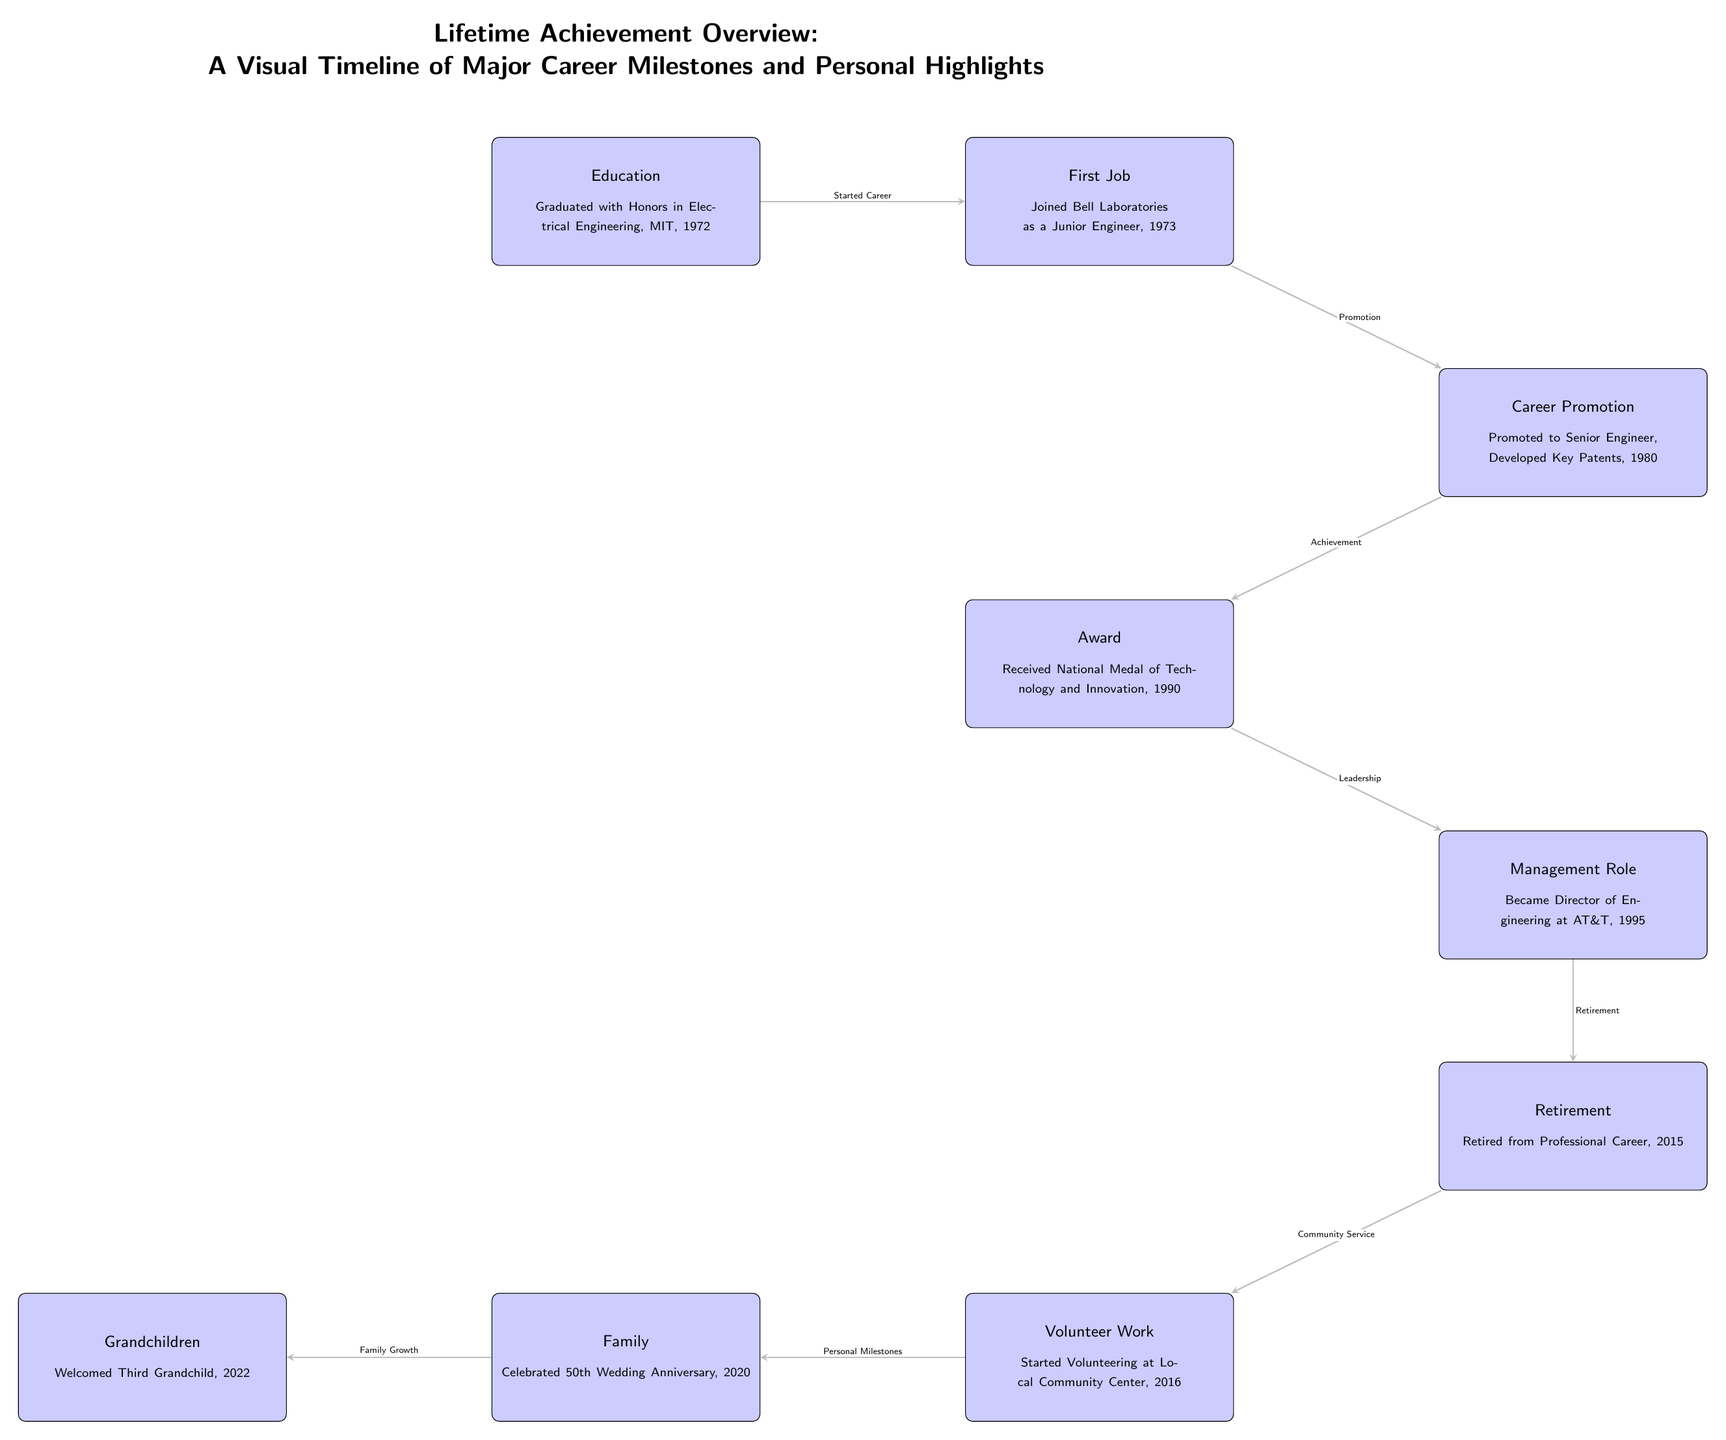What year did the retirement occur? The retirement event is represented in the diagram. By examining the node labeled 'Retirement,' it notes that the retirement occurred in 2015.
Answer: 2015 How many major career milestones are shown in the diagram? Counting the nodes that represent career milestones only (Education, First Job, Career Promotion, Award, Management Role, Retirement), we find a total of six nodes indicating major career milestones.
Answer: 6 What was the first job mentioned? Looking at the node labeled 'First Job,' it specifies that the first job was at Bell Laboratories as a Junior Engineer.
Answer: Joined Bell Laboratories as a Junior Engineer What event followed the career promotion? By analyzing the flow of the diagram, the event that follows 'Career Promotion' is 'Award,' as indicated by the connecting arrow between these two nodes.
Answer: Award What personal milestone occurred in 2020? In the timeline, the node labeled 'Family' indicates that the personal milestone celebrated was the 50th wedding anniversary, which occurred in 2020.
Answer: Celebrated 50th Wedding Anniversary Which event signifies the start of community service? From the diagram, the arrow leading from 'Retirement' to 'Volunteer Work' signifies that starting the volunteer work at the local community center is the event representing the beginning of community service.
Answer: Started Volunteering at Local Community Center What significant award was received in 1990? Looking at the node labeled 'Award,' it states that the National Medal of Technology and Innovation was received in 1990, identifying the significant achievement noted in the diagram.
Answer: National Medal of Technology and Innovation What role was held at AT&T in 1995? The diagram clearly identifies that in 1995, the role held was 'Director of Engineering at AT&T,' as captured in the Management Role node.
Answer: Director of Engineering at AT&T 